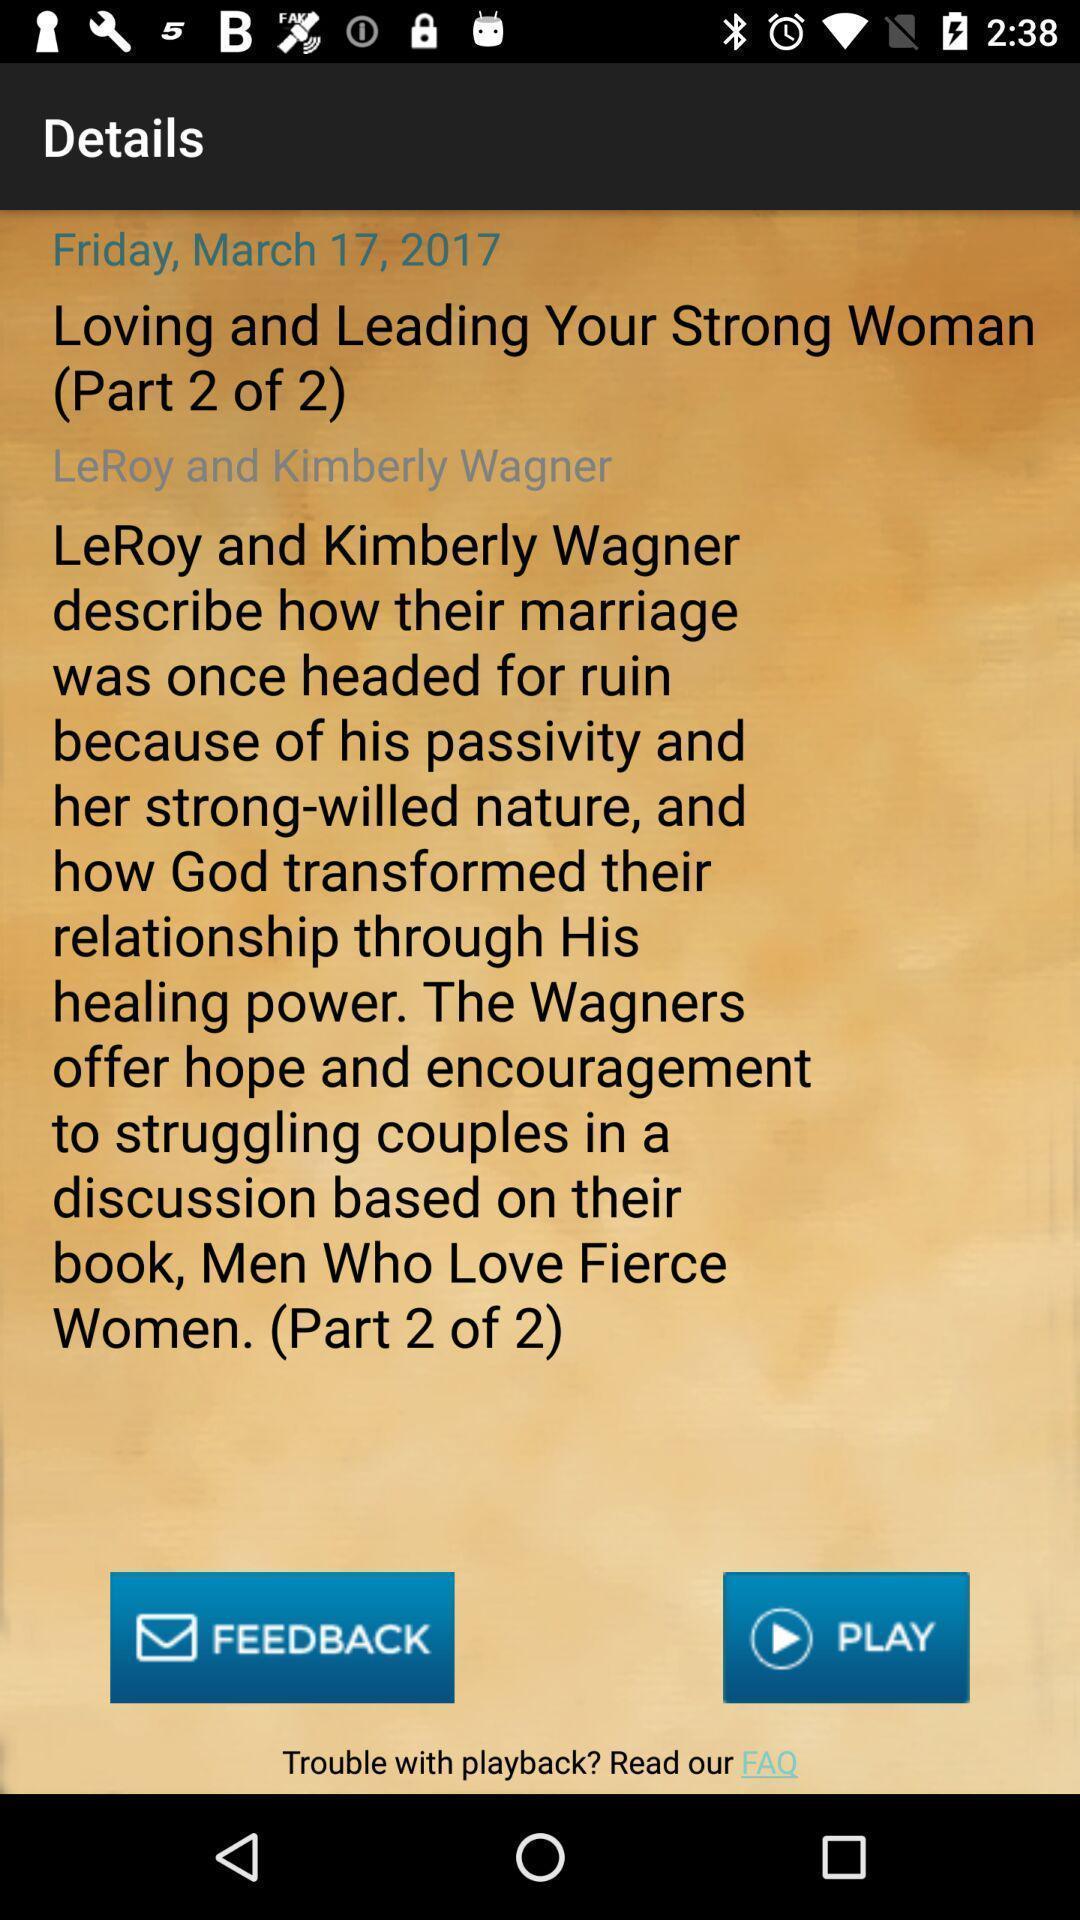Please provide a description for this image. Page showing different option like play. 